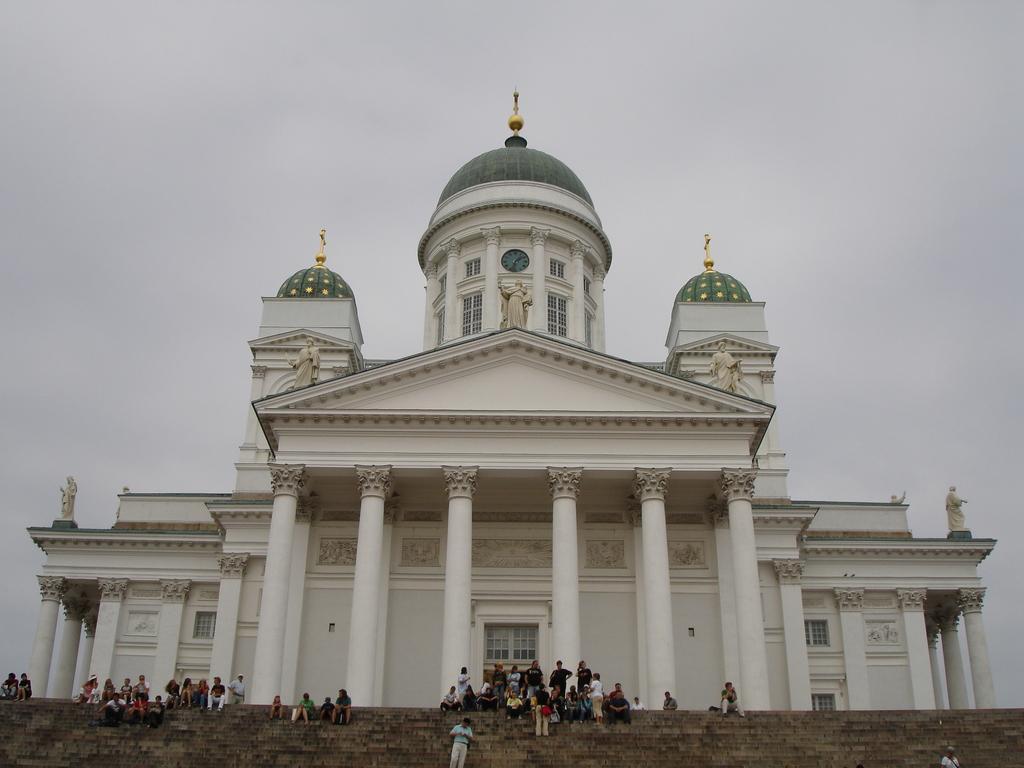Can you describe this image briefly? Here in this picture we can see a monumental building present over a place and we can see steps present and in the middle we can see pillars present and we can see a door and windows present on the building and at the top we can see statues present and we can see the sky is cloudy and we can see number of people sitting and standing on the steps over there. 